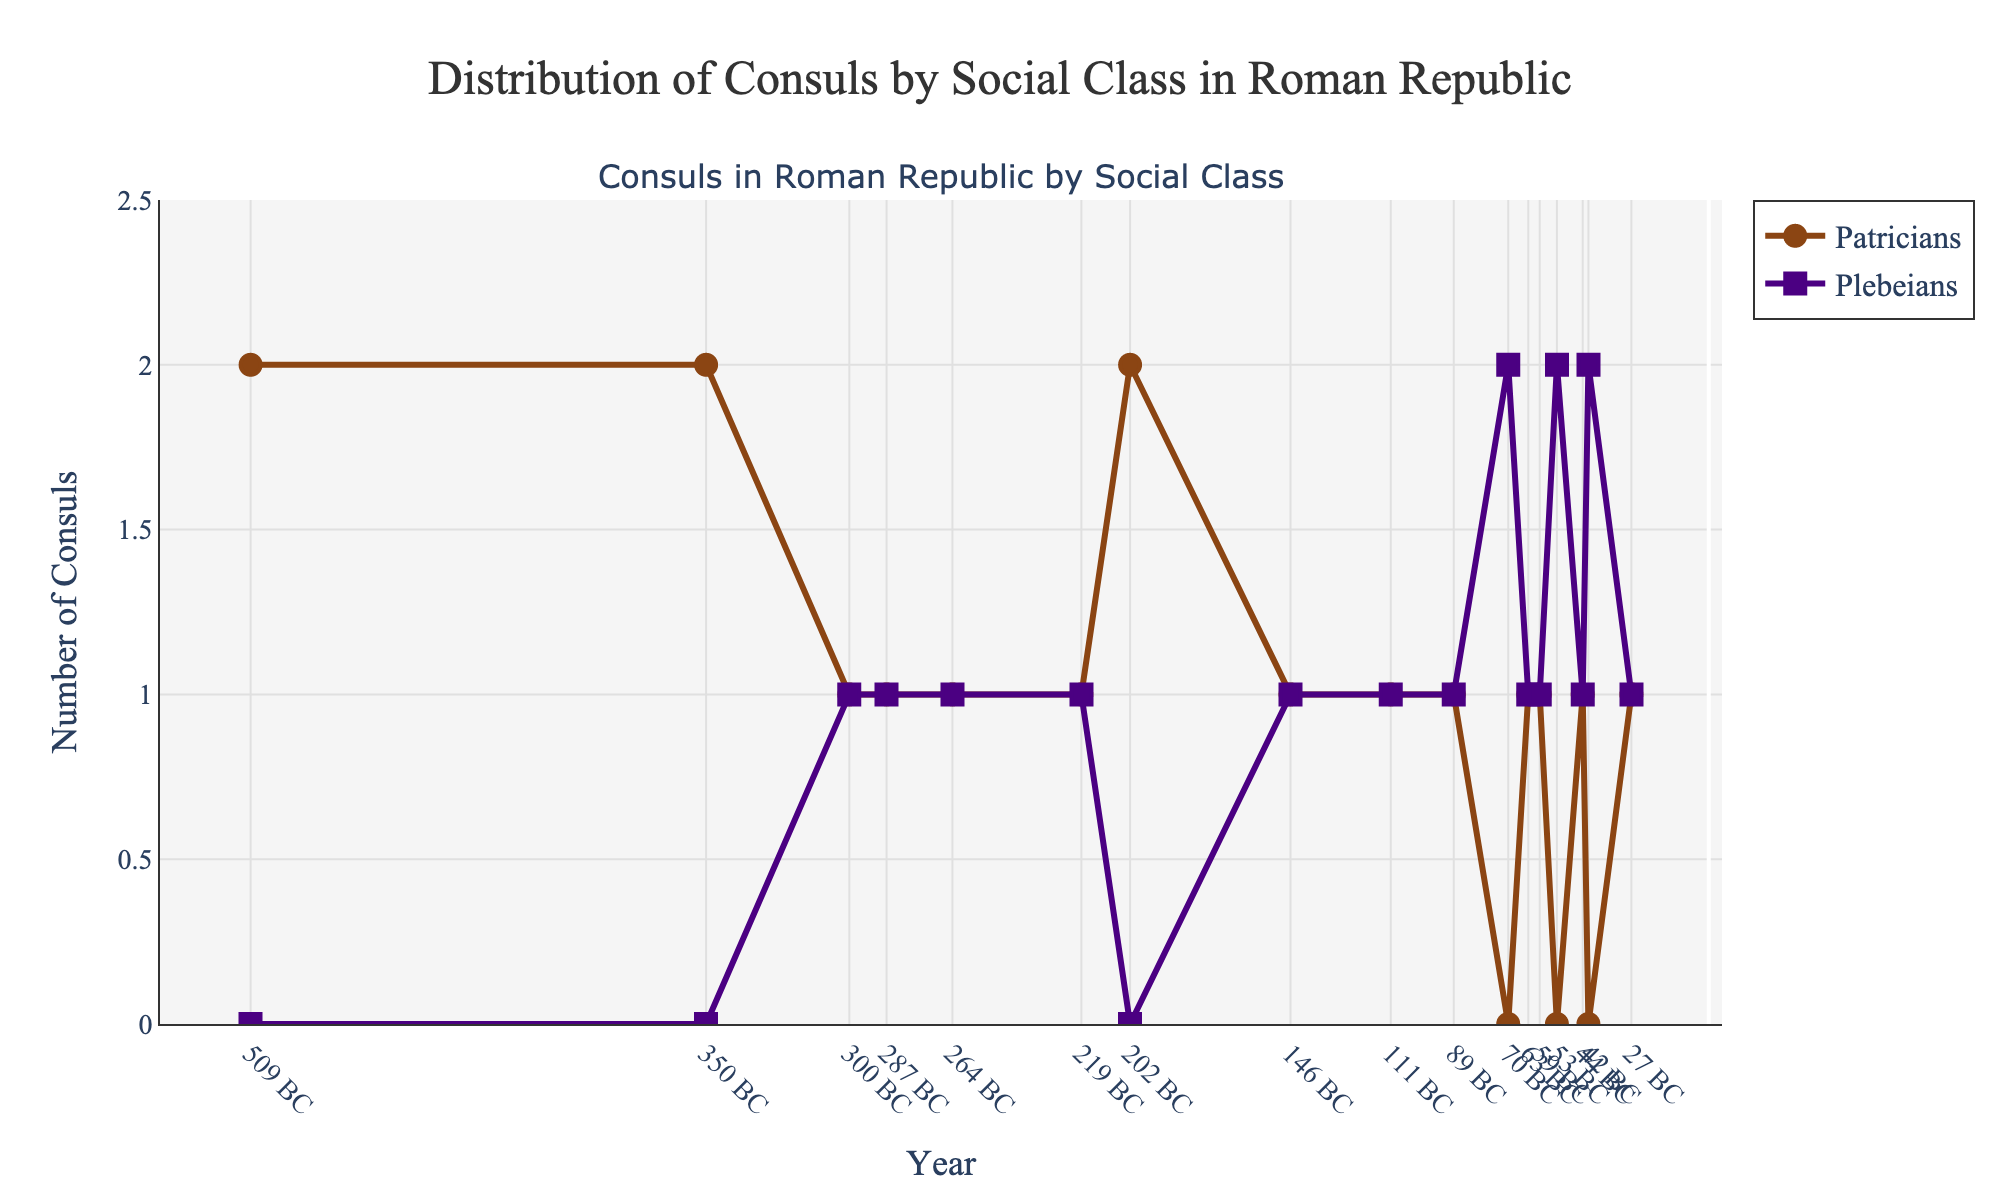What is the title of the plot? The title of the plot is located at the top center. It states the main purpose of the plot, which is to illustrate the distribution of consuls by their social class in the Roman Republic.
Answer: Distribution of Consuls by Social Class in Roman Republic How many consuls were elected annually from 509 BC to 27 BC? To find the number of consuls elected annually, check the y-axis label and the data points in the series. Each point indicates that exactly two consuls were elected annually.
Answer: 2 In which years did Plebeians exclusively hold the consulship? Look for the points where the Plebeians' line (purple) reaches 2 and the Patricians' line (brown) is at 0 on the y-axis. These years are when Plebeians exclusively held the consulship. This occurs in 70 BC, 53 BC, and 42 BC.
Answer: 70 BC, 53 BC, 42 BC Which social class had more consuls in 111 BC? Compare the y-values of Patricians (brown) and Plebeians (purple) in 111 BC. The Patricians had 1 consul, and so did the Plebeians.
Answer: Both had 1 consul How did the composition of consuls change between 350 BC and 70 BC? In 350 BC, all consuls were Patricians. By 70 BC, all consuls were Plebeians. This indicates a significant shift from Patrician to Plebeian dominance over the period.
Answer: From Patricians to Plebeians How many times in the data did both social classes hold an equal number of consulships? Count the data points where Patricians and Plebeians hold the same y-axis value, which is represented where both lines intersect at 1 on the plot. It occurs at 300 BC, 287 BC, 264 BC, 219 BC, 146 BC, 89 BC, 63 BC, and 27 BC.
Answer: 8 times What trend is noticeable about the number of Plebeian consuls from 350 BC to 42 BC? By tracking the purple line from 350 BC to 42 BC, the number of Plebeian consuls increased over time, eventually even surpassing the Patricians in certain years.
Answer: Increasing trend What was the social composition of consuls at the end of the Roman Republic in 27 BC? In 27 BC, the plot shows 1 Patrician and 1 Plebeian consul, as indicated by the values of the brown and purple lines at this year.
Answer: 1 Patrician and 1 Plebeian Compare the number of Patrician consuls in 509 BC and 202 BC. Check the y-values for Patricians (brown line) at these two years. Both years show that there were 2 Patrician consuls.
Answer: Equal Why is the y-axis range set from 0 to 2.5? The y-axis ranges from 0 to 2.5 to accommodate the visualization of a maximum of 2 consuls per social class, while providing a slight buffer above the maximum value for clarity.
Answer: To fit the data comfortably within the plot 